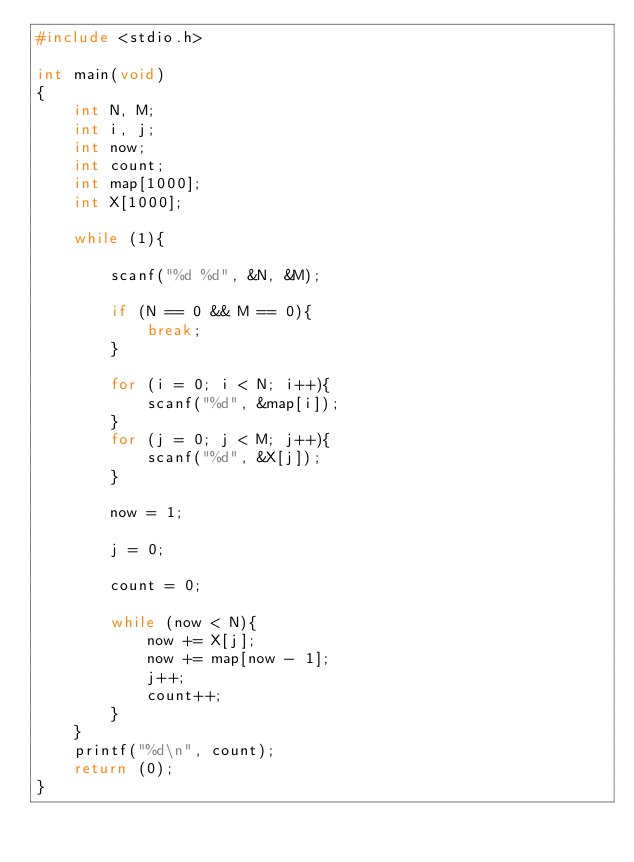<code> <loc_0><loc_0><loc_500><loc_500><_C_>#include <stdio.h>

int main(void)
{
	int N, M;
	int i, j;
	int now;
	int count;
	int map[1000];
	int X[1000];
	
	while (1){
	
		scanf("%d %d", &N, &M);
		
		if (N == 0 && M == 0){
			break;
		}
		
		for (i = 0; i < N; i++){
			scanf("%d", &map[i]);
		}
		for (j = 0; j < M; j++){
			scanf("%d", &X[j]);
		}
		
		now = 1;
		
		j = 0;
		
		count = 0;
		
		while (now < N){
			now += X[j];
			now += map[now - 1];
			j++;
			count++;
		}
	}
	printf("%d\n", count);
	return (0);
}</code> 